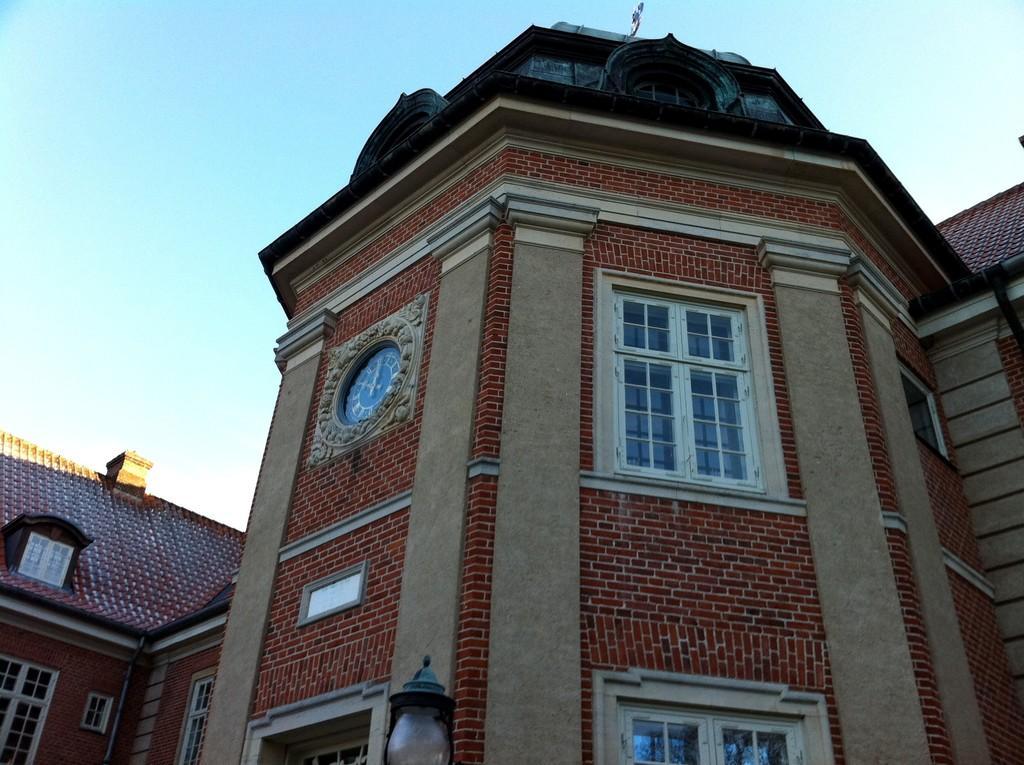How would you summarize this image in a sentence or two? In this image in front there are buildings. There is a light. In the background of the image there is sky. 